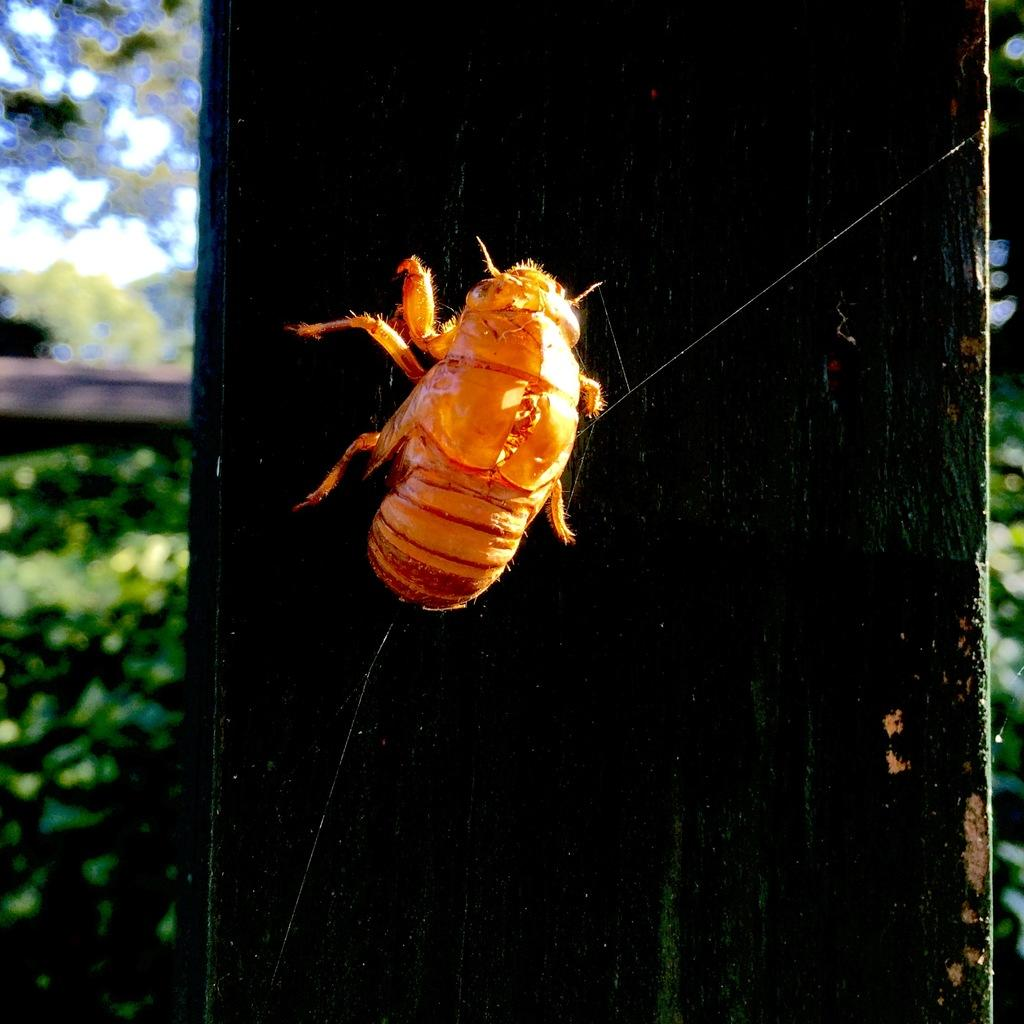What type of structure can be seen in the image? There is a wooden pillar in the image. What is on the wooden pillar? An insect is present on the wooden pillar. What can be seen in the background of the image? There are plants visible in the background of the image. How would you describe the background of the image? The background of the image appears blurry. What force is causing the faucet to leak in the image? There is no faucet present in the image, so it is not possible to determine if there is a leak or any force causing it. 